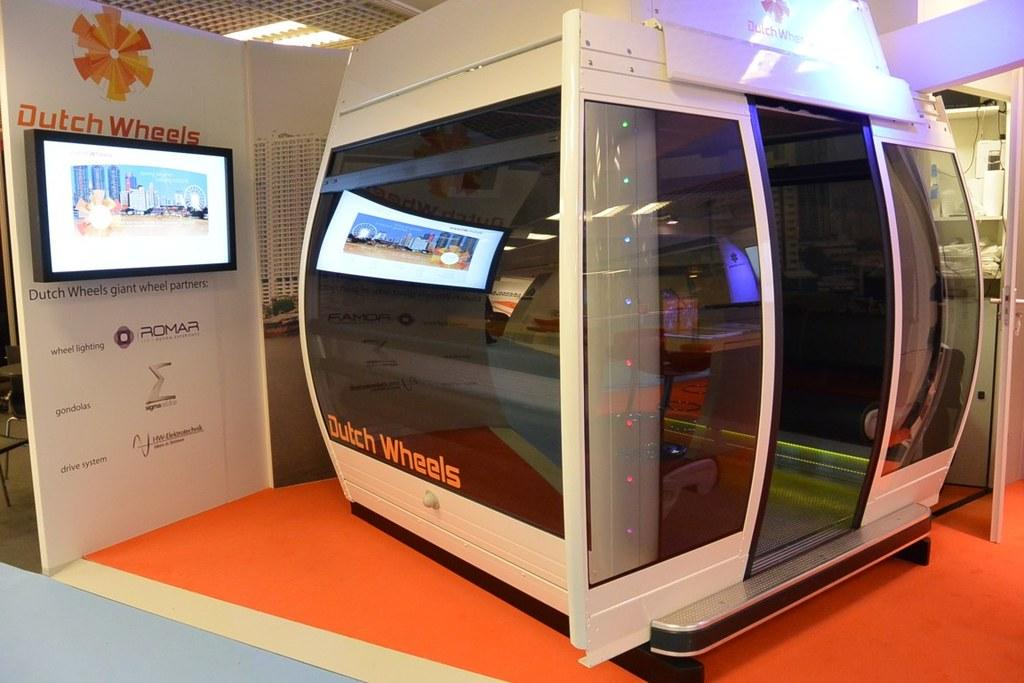<image>
Share a concise interpretation of the image provided. Inside simulator device that says Dutch Wheels, says Giant Wheel Partners: Romar. 